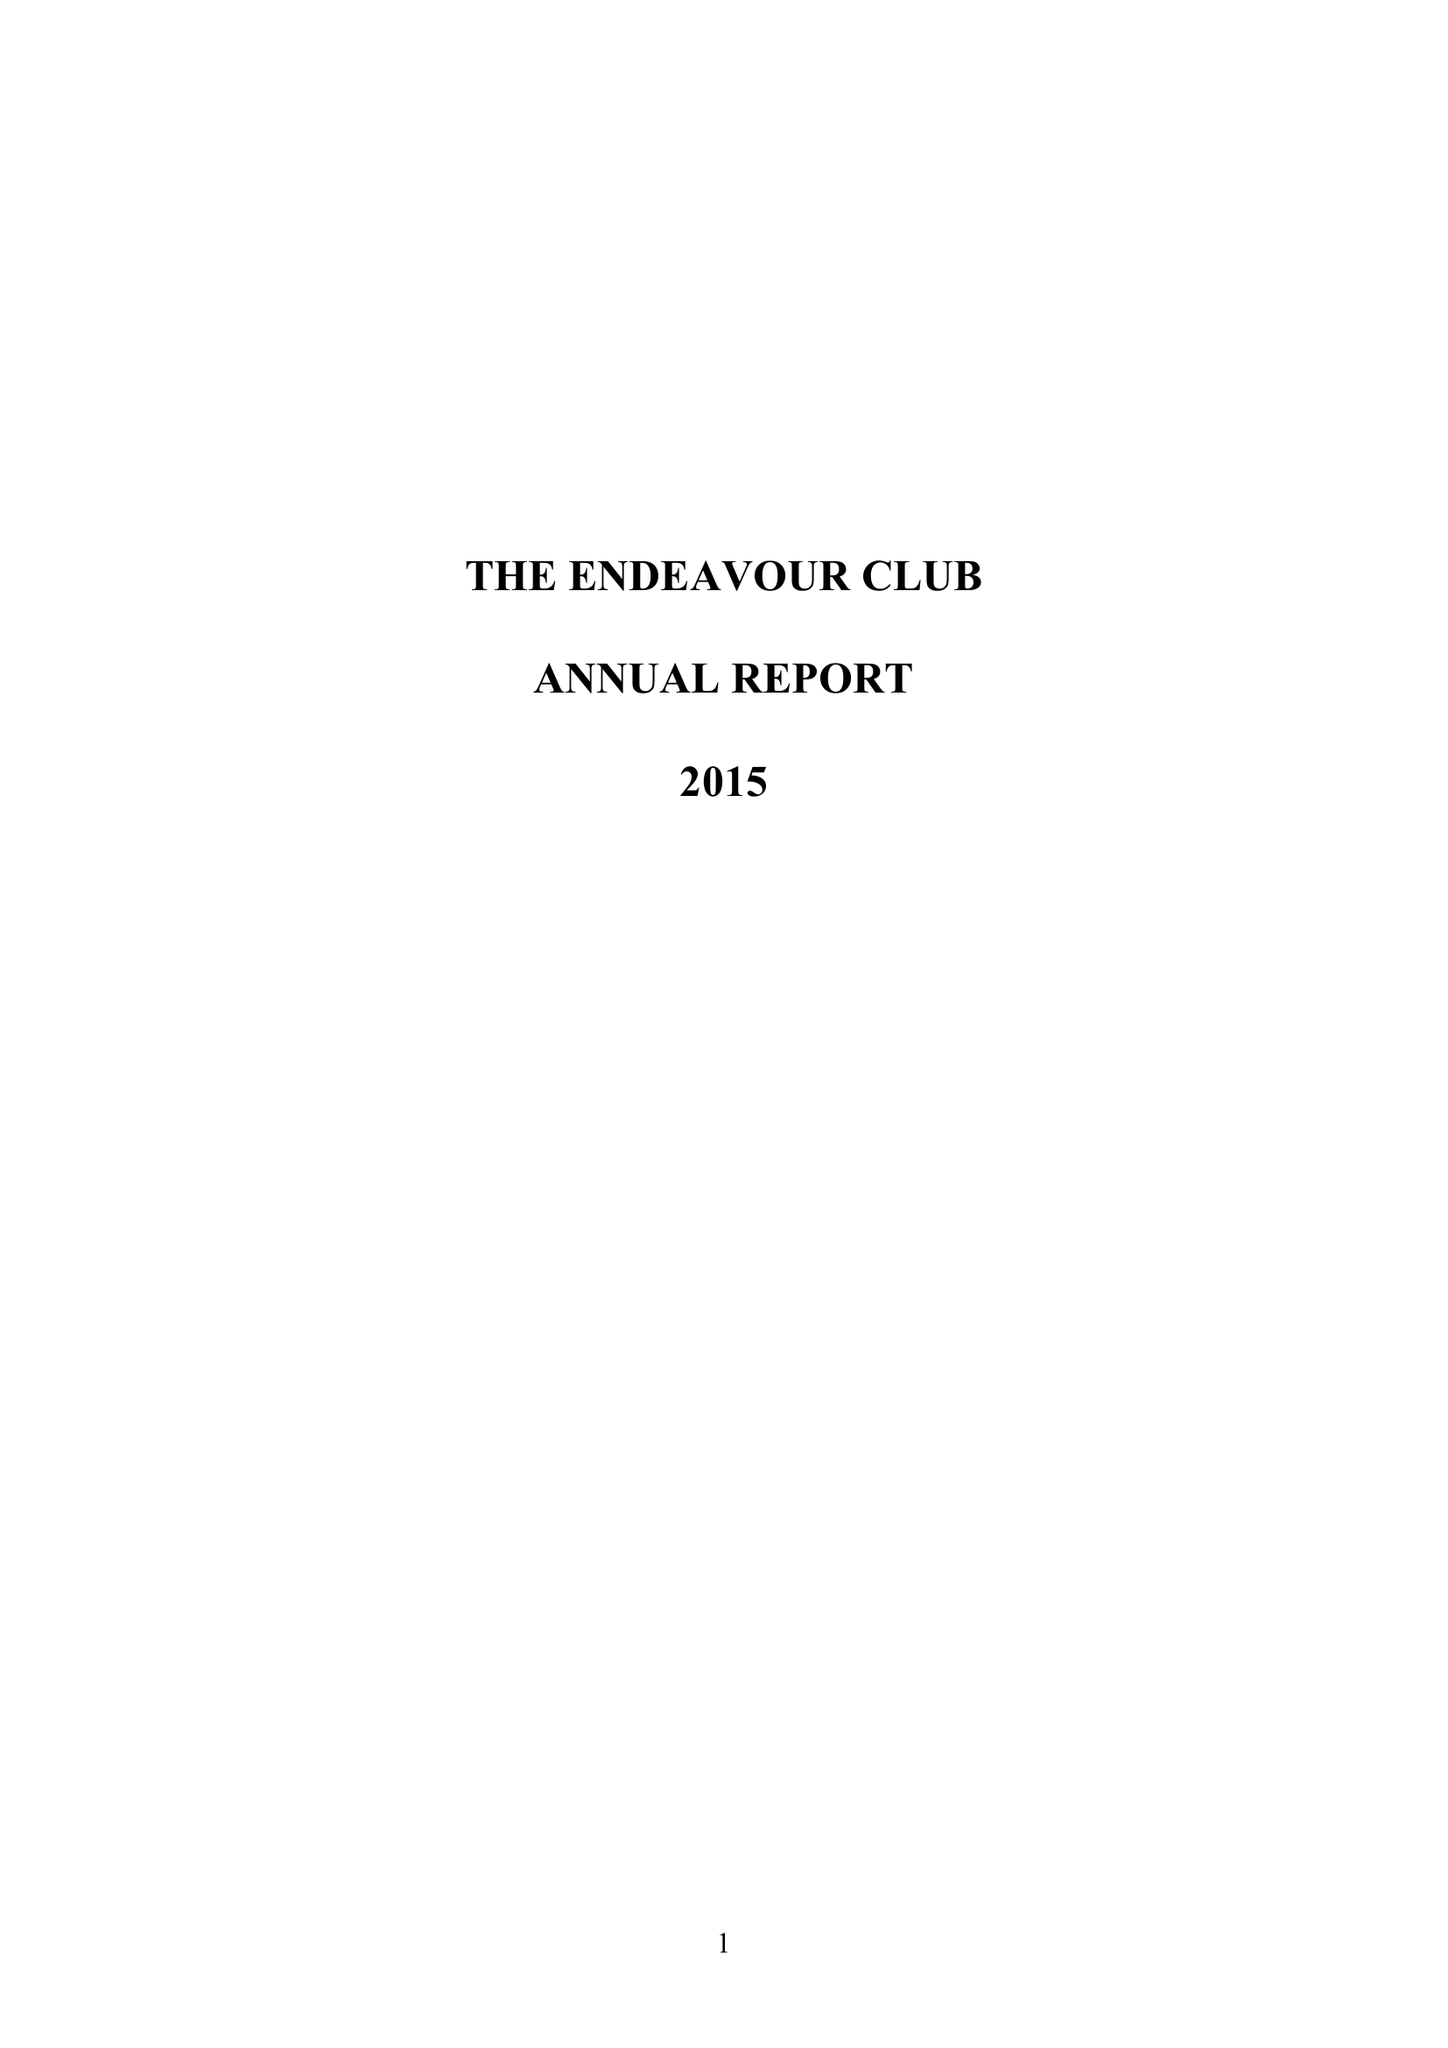What is the value for the charity_number?
Answer the question using a single word or phrase. 303161 